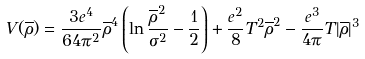Convert formula to latex. <formula><loc_0><loc_0><loc_500><loc_500>V ( \overline { \rho } ) = \frac { 3 e ^ { 4 } } { 6 4 \pi ^ { 2 } } \overline { \rho } ^ { 4 } \left ( \ln \frac { \overline { \rho } ^ { 2 } } { \sigma ^ { 2 } } - \frac { 1 } { 2 } \right ) + \frac { e ^ { 2 } } { 8 } T ^ { 2 } \overline { \rho } ^ { 2 } - \frac { e ^ { 3 } } { 4 \pi } T | \overline { \rho } | ^ { 3 }</formula> 